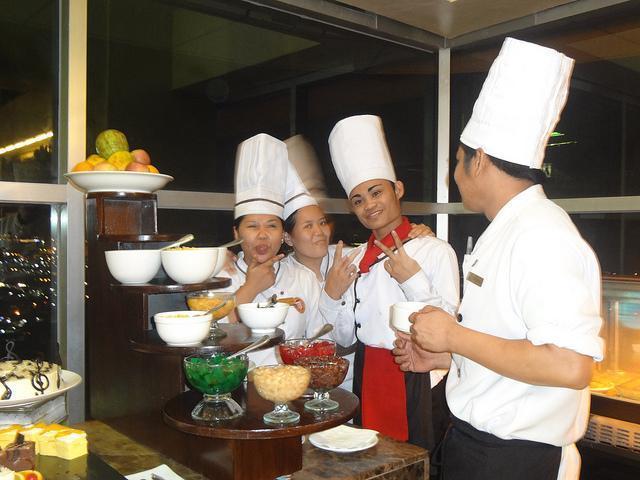How many chefs are in this scene?
Give a very brief answer. 4. How many people are there?
Give a very brief answer. 4. How many bowls are there?
Give a very brief answer. 2. How many cars are in the picture before the overhead signs?
Give a very brief answer. 0. 